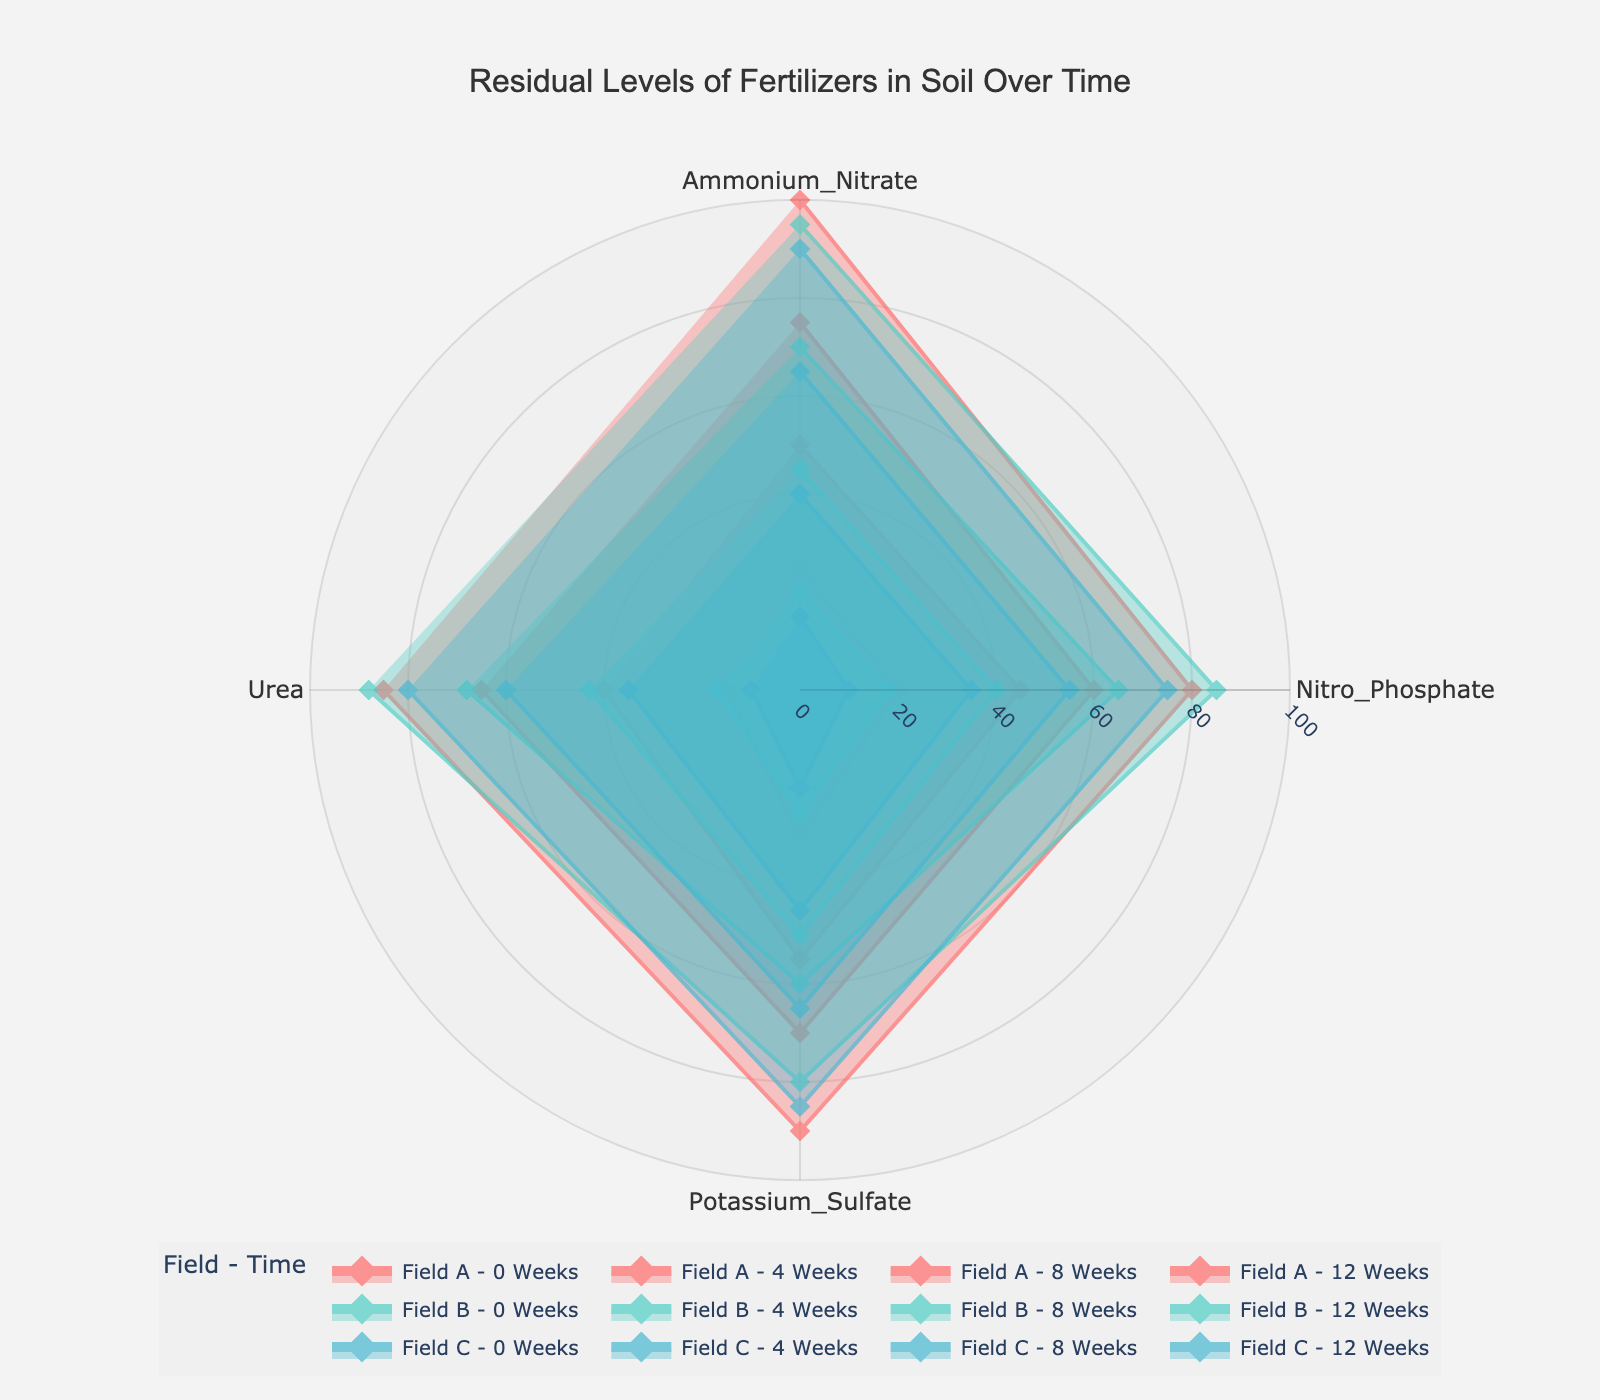what is the title of the figure? The title of the figure is usually found at the top and summarizes the contents of the chart. In this case, the title reads "Residual Levels of Fertilizers in Soil Over Time".
Answer: Residual Levels of Fertilizers in Soil Over Time How many groups (fields) are represented on the radar chart? To determine the number of groups, observe the legend, which indicates different named entities. The legend shows three groups: "Field A", "Field B", and "Field C".
Answer: 3 What fertilizer has the highest level at 0 weeks for Field B? To find this value, look at the points corresponding to "Field B - 0 Weeks" on the radar chart. The highest value is for Urea, which is 88.
Answer: Urea How do the ammonium nitrate levels change over 12 weeks for Field A? To identify this, track the ammonium nitrate values for Field A over the timeline provided in the radar chart. The values are 100 at 0 Weeks, 75 at 4 Weeks, 50 at 8 Weeks, and 25 at 12 Weeks. These values show a consistent decrease over time.
Answer: They decrease from 100 to 25 Which field shows the least residual levels of nitro phosphate at 8 weeks? Look at the data points for each group at the 8-week mark. For "Field A - 8 Weeks", nitro phosphate is 45. For "Field B - 8 Weeks", it's 40. For "Field C - 8 Weeks", it's 35. Thus, Field C has the least residual levels of nitro phosphate at 8 weeks.
Answer: Field C What is the average residual level of urea for Field C over all time points? First, obtain the urea values for Field C at each time point: 80 (0 Weeks), 60 (4 Weeks), 35 (8 Weeks), and 10 (12 Weeks). Sum these values (80 + 60 + 35 + 10 = 185) and divide by the number of time points (4). The average is 185/4 = 46.25.
Answer: 46.25 Compare the levels of potassium sulfate for Field A and Field B at 4 weeks. Which one is higher? Examine the potassium sulfate levels at 4 weeks for both fields: Field A at 4 Weeks is 70 and Field B at 4 Weeks is 60. Thus, Field A has higher levels of potassium sulfate at 4 weeks.
Answer: Field A Which fertilizer is consistently the lowest in residual levels for Field C over all time points? Track each fertilizer's values for Field C across all time points and observe their trends. Urea at 0 Weeks is 80, 4 Weeks is 60, 8 Weeks is 35, and 12 Weeks is 10. Compare it to other fertilizers and note that Nitro Phosphate starts at 75, which drops to 10 at 12 weeks. Nitro Phosphate consistently has low residual levels compared to other fertilizers.
Answer: Nitro Phosphate What is the difference in ammonium nitrate levels between 0 weeks and 12 weeks for Field B? Locate the ammonium nitrate levels for Field B at 0 Weeks and 12 Weeks: 95 and 20, respectively. Subtract the 12 Weeks value from the 0 Weeks value (95 - 20 = 75).
Answer: 75 